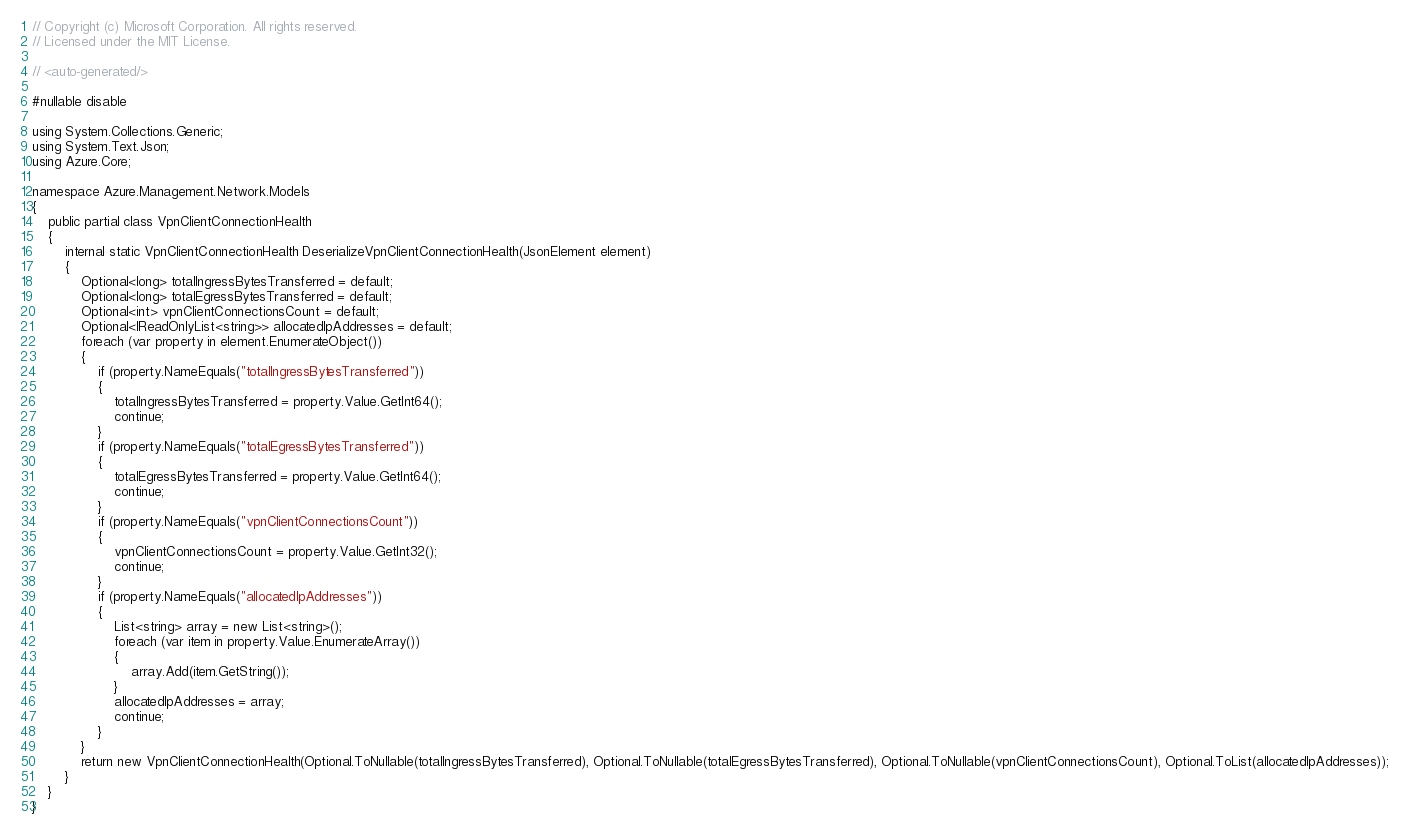<code> <loc_0><loc_0><loc_500><loc_500><_C#_>// Copyright (c) Microsoft Corporation. All rights reserved.
// Licensed under the MIT License.

// <auto-generated/>

#nullable disable

using System.Collections.Generic;
using System.Text.Json;
using Azure.Core;

namespace Azure.Management.Network.Models
{
    public partial class VpnClientConnectionHealth
    {
        internal static VpnClientConnectionHealth DeserializeVpnClientConnectionHealth(JsonElement element)
        {
            Optional<long> totalIngressBytesTransferred = default;
            Optional<long> totalEgressBytesTransferred = default;
            Optional<int> vpnClientConnectionsCount = default;
            Optional<IReadOnlyList<string>> allocatedIpAddresses = default;
            foreach (var property in element.EnumerateObject())
            {
                if (property.NameEquals("totalIngressBytesTransferred"))
                {
                    totalIngressBytesTransferred = property.Value.GetInt64();
                    continue;
                }
                if (property.NameEquals("totalEgressBytesTransferred"))
                {
                    totalEgressBytesTransferred = property.Value.GetInt64();
                    continue;
                }
                if (property.NameEquals("vpnClientConnectionsCount"))
                {
                    vpnClientConnectionsCount = property.Value.GetInt32();
                    continue;
                }
                if (property.NameEquals("allocatedIpAddresses"))
                {
                    List<string> array = new List<string>();
                    foreach (var item in property.Value.EnumerateArray())
                    {
                        array.Add(item.GetString());
                    }
                    allocatedIpAddresses = array;
                    continue;
                }
            }
            return new VpnClientConnectionHealth(Optional.ToNullable(totalIngressBytesTransferred), Optional.ToNullable(totalEgressBytesTransferred), Optional.ToNullable(vpnClientConnectionsCount), Optional.ToList(allocatedIpAddresses));
        }
    }
}
</code> 